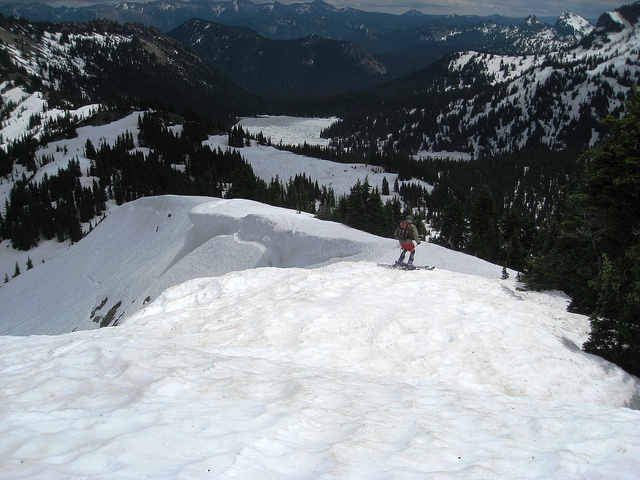Describe the objects in this image and their specific colors. I can see people in blue, gray, black, and maroon tones, backpack in blue, black, gray, maroon, and brown tones, and skis in blue, darkgray, gray, and lightgray tones in this image. 